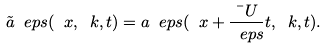Convert formula to latex. <formula><loc_0><loc_0><loc_500><loc_500>\tilde { a } _ { \ } e p s ( \ x , \ k , t ) = a _ { \ } e p s ( \ x + \frac { \bar { \ } U } { \ e p s } t , \ k , t ) .</formula> 